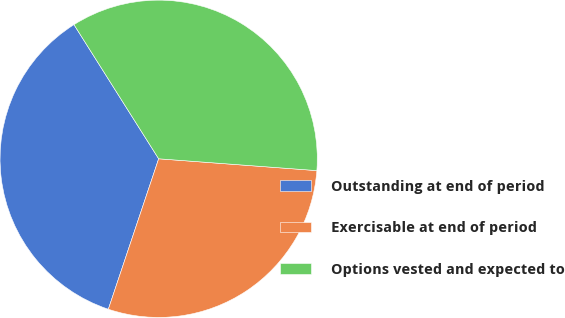Convert chart. <chart><loc_0><loc_0><loc_500><loc_500><pie_chart><fcel>Outstanding at end of period<fcel>Exercisable at end of period<fcel>Options vested and expected to<nl><fcel>35.9%<fcel>28.95%<fcel>35.15%<nl></chart> 